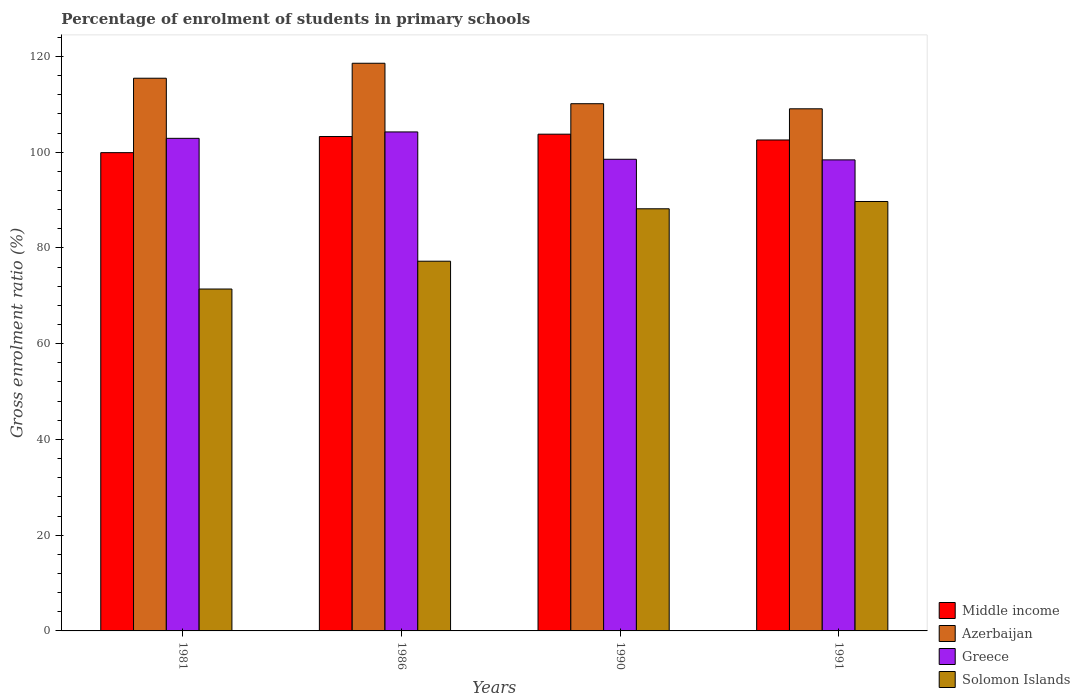How many groups of bars are there?
Keep it short and to the point. 4. Are the number of bars per tick equal to the number of legend labels?
Offer a very short reply. Yes. Are the number of bars on each tick of the X-axis equal?
Offer a terse response. Yes. How many bars are there on the 2nd tick from the left?
Provide a succinct answer. 4. What is the label of the 3rd group of bars from the left?
Give a very brief answer. 1990. In how many cases, is the number of bars for a given year not equal to the number of legend labels?
Provide a short and direct response. 0. What is the percentage of students enrolled in primary schools in Middle income in 1990?
Keep it short and to the point. 103.76. Across all years, what is the maximum percentage of students enrolled in primary schools in Azerbaijan?
Give a very brief answer. 118.57. Across all years, what is the minimum percentage of students enrolled in primary schools in Greece?
Your answer should be compact. 98.39. In which year was the percentage of students enrolled in primary schools in Solomon Islands minimum?
Provide a succinct answer. 1981. What is the total percentage of students enrolled in primary schools in Middle income in the graph?
Ensure brevity in your answer.  409.47. What is the difference between the percentage of students enrolled in primary schools in Azerbaijan in 1990 and that in 1991?
Give a very brief answer. 1.06. What is the difference between the percentage of students enrolled in primary schools in Middle income in 1986 and the percentage of students enrolled in primary schools in Azerbaijan in 1990?
Keep it short and to the point. -6.86. What is the average percentage of students enrolled in primary schools in Middle income per year?
Your answer should be very brief. 102.37. In the year 1981, what is the difference between the percentage of students enrolled in primary schools in Solomon Islands and percentage of students enrolled in primary schools in Azerbaijan?
Make the answer very short. -44.03. What is the ratio of the percentage of students enrolled in primary schools in Azerbaijan in 1990 to that in 1991?
Make the answer very short. 1.01. Is the difference between the percentage of students enrolled in primary schools in Solomon Islands in 1990 and 1991 greater than the difference between the percentage of students enrolled in primary schools in Azerbaijan in 1990 and 1991?
Make the answer very short. No. What is the difference between the highest and the second highest percentage of students enrolled in primary schools in Solomon Islands?
Offer a terse response. 1.52. What is the difference between the highest and the lowest percentage of students enrolled in primary schools in Azerbaijan?
Your answer should be very brief. 9.51. In how many years, is the percentage of students enrolled in primary schools in Middle income greater than the average percentage of students enrolled in primary schools in Middle income taken over all years?
Your answer should be very brief. 3. Is the sum of the percentage of students enrolled in primary schools in Solomon Islands in 1986 and 1990 greater than the maximum percentage of students enrolled in primary schools in Middle income across all years?
Provide a short and direct response. Yes. What does the 2nd bar from the left in 1981 represents?
Provide a succinct answer. Azerbaijan. Is it the case that in every year, the sum of the percentage of students enrolled in primary schools in Greece and percentage of students enrolled in primary schools in Solomon Islands is greater than the percentage of students enrolled in primary schools in Middle income?
Keep it short and to the point. Yes. How many bars are there?
Ensure brevity in your answer.  16. Are all the bars in the graph horizontal?
Keep it short and to the point. No. Where does the legend appear in the graph?
Keep it short and to the point. Bottom right. How many legend labels are there?
Provide a succinct answer. 4. What is the title of the graph?
Ensure brevity in your answer.  Percentage of enrolment of students in primary schools. Does "Lithuania" appear as one of the legend labels in the graph?
Offer a very short reply. No. What is the Gross enrolment ratio (%) in Middle income in 1981?
Make the answer very short. 99.9. What is the Gross enrolment ratio (%) in Azerbaijan in 1981?
Provide a succinct answer. 115.44. What is the Gross enrolment ratio (%) in Greece in 1981?
Provide a short and direct response. 102.89. What is the Gross enrolment ratio (%) in Solomon Islands in 1981?
Keep it short and to the point. 71.41. What is the Gross enrolment ratio (%) in Middle income in 1986?
Make the answer very short. 103.27. What is the Gross enrolment ratio (%) of Azerbaijan in 1986?
Offer a terse response. 118.57. What is the Gross enrolment ratio (%) of Greece in 1986?
Offer a terse response. 104.22. What is the Gross enrolment ratio (%) of Solomon Islands in 1986?
Your answer should be very brief. 77.22. What is the Gross enrolment ratio (%) in Middle income in 1990?
Your response must be concise. 103.76. What is the Gross enrolment ratio (%) of Azerbaijan in 1990?
Make the answer very short. 110.12. What is the Gross enrolment ratio (%) in Greece in 1990?
Offer a terse response. 98.51. What is the Gross enrolment ratio (%) of Solomon Islands in 1990?
Your answer should be compact. 88.17. What is the Gross enrolment ratio (%) in Middle income in 1991?
Make the answer very short. 102.55. What is the Gross enrolment ratio (%) of Azerbaijan in 1991?
Make the answer very short. 109.06. What is the Gross enrolment ratio (%) in Greece in 1991?
Ensure brevity in your answer.  98.39. What is the Gross enrolment ratio (%) of Solomon Islands in 1991?
Provide a short and direct response. 89.7. Across all years, what is the maximum Gross enrolment ratio (%) of Middle income?
Offer a terse response. 103.76. Across all years, what is the maximum Gross enrolment ratio (%) in Azerbaijan?
Your answer should be compact. 118.57. Across all years, what is the maximum Gross enrolment ratio (%) in Greece?
Give a very brief answer. 104.22. Across all years, what is the maximum Gross enrolment ratio (%) of Solomon Islands?
Your response must be concise. 89.7. Across all years, what is the minimum Gross enrolment ratio (%) of Middle income?
Your response must be concise. 99.9. Across all years, what is the minimum Gross enrolment ratio (%) of Azerbaijan?
Your answer should be very brief. 109.06. Across all years, what is the minimum Gross enrolment ratio (%) of Greece?
Make the answer very short. 98.39. Across all years, what is the minimum Gross enrolment ratio (%) of Solomon Islands?
Give a very brief answer. 71.41. What is the total Gross enrolment ratio (%) in Middle income in the graph?
Your answer should be very brief. 409.47. What is the total Gross enrolment ratio (%) of Azerbaijan in the graph?
Offer a very short reply. 453.19. What is the total Gross enrolment ratio (%) in Greece in the graph?
Your answer should be very brief. 404.01. What is the total Gross enrolment ratio (%) in Solomon Islands in the graph?
Provide a succinct answer. 326.51. What is the difference between the Gross enrolment ratio (%) of Middle income in 1981 and that in 1986?
Provide a succinct answer. -3.37. What is the difference between the Gross enrolment ratio (%) of Azerbaijan in 1981 and that in 1986?
Provide a succinct answer. -3.13. What is the difference between the Gross enrolment ratio (%) of Greece in 1981 and that in 1986?
Give a very brief answer. -1.34. What is the difference between the Gross enrolment ratio (%) of Solomon Islands in 1981 and that in 1986?
Make the answer very short. -5.81. What is the difference between the Gross enrolment ratio (%) in Middle income in 1981 and that in 1990?
Provide a succinct answer. -3.86. What is the difference between the Gross enrolment ratio (%) in Azerbaijan in 1981 and that in 1990?
Provide a short and direct response. 5.32. What is the difference between the Gross enrolment ratio (%) of Greece in 1981 and that in 1990?
Offer a terse response. 4.38. What is the difference between the Gross enrolment ratio (%) of Solomon Islands in 1981 and that in 1990?
Provide a succinct answer. -16.76. What is the difference between the Gross enrolment ratio (%) of Middle income in 1981 and that in 1991?
Offer a very short reply. -2.65. What is the difference between the Gross enrolment ratio (%) in Azerbaijan in 1981 and that in 1991?
Your answer should be very brief. 6.39. What is the difference between the Gross enrolment ratio (%) of Greece in 1981 and that in 1991?
Your answer should be compact. 4.5. What is the difference between the Gross enrolment ratio (%) of Solomon Islands in 1981 and that in 1991?
Your answer should be compact. -18.28. What is the difference between the Gross enrolment ratio (%) of Middle income in 1986 and that in 1990?
Your response must be concise. -0.49. What is the difference between the Gross enrolment ratio (%) of Azerbaijan in 1986 and that in 1990?
Offer a very short reply. 8.45. What is the difference between the Gross enrolment ratio (%) of Greece in 1986 and that in 1990?
Offer a very short reply. 5.71. What is the difference between the Gross enrolment ratio (%) in Solomon Islands in 1986 and that in 1990?
Your answer should be very brief. -10.95. What is the difference between the Gross enrolment ratio (%) of Middle income in 1986 and that in 1991?
Ensure brevity in your answer.  0.72. What is the difference between the Gross enrolment ratio (%) in Azerbaijan in 1986 and that in 1991?
Provide a succinct answer. 9.51. What is the difference between the Gross enrolment ratio (%) in Greece in 1986 and that in 1991?
Keep it short and to the point. 5.84. What is the difference between the Gross enrolment ratio (%) in Solomon Islands in 1986 and that in 1991?
Give a very brief answer. -12.47. What is the difference between the Gross enrolment ratio (%) of Middle income in 1990 and that in 1991?
Your answer should be very brief. 1.21. What is the difference between the Gross enrolment ratio (%) of Azerbaijan in 1990 and that in 1991?
Your answer should be very brief. 1.06. What is the difference between the Gross enrolment ratio (%) in Greece in 1990 and that in 1991?
Your answer should be compact. 0.13. What is the difference between the Gross enrolment ratio (%) of Solomon Islands in 1990 and that in 1991?
Provide a short and direct response. -1.52. What is the difference between the Gross enrolment ratio (%) of Middle income in 1981 and the Gross enrolment ratio (%) of Azerbaijan in 1986?
Give a very brief answer. -18.67. What is the difference between the Gross enrolment ratio (%) of Middle income in 1981 and the Gross enrolment ratio (%) of Greece in 1986?
Offer a very short reply. -4.32. What is the difference between the Gross enrolment ratio (%) in Middle income in 1981 and the Gross enrolment ratio (%) in Solomon Islands in 1986?
Keep it short and to the point. 22.68. What is the difference between the Gross enrolment ratio (%) of Azerbaijan in 1981 and the Gross enrolment ratio (%) of Greece in 1986?
Give a very brief answer. 11.22. What is the difference between the Gross enrolment ratio (%) of Azerbaijan in 1981 and the Gross enrolment ratio (%) of Solomon Islands in 1986?
Your response must be concise. 38.22. What is the difference between the Gross enrolment ratio (%) of Greece in 1981 and the Gross enrolment ratio (%) of Solomon Islands in 1986?
Your answer should be very brief. 25.67. What is the difference between the Gross enrolment ratio (%) of Middle income in 1981 and the Gross enrolment ratio (%) of Azerbaijan in 1990?
Your response must be concise. -10.22. What is the difference between the Gross enrolment ratio (%) of Middle income in 1981 and the Gross enrolment ratio (%) of Greece in 1990?
Your response must be concise. 1.39. What is the difference between the Gross enrolment ratio (%) of Middle income in 1981 and the Gross enrolment ratio (%) of Solomon Islands in 1990?
Offer a very short reply. 11.73. What is the difference between the Gross enrolment ratio (%) in Azerbaijan in 1981 and the Gross enrolment ratio (%) in Greece in 1990?
Offer a very short reply. 16.93. What is the difference between the Gross enrolment ratio (%) of Azerbaijan in 1981 and the Gross enrolment ratio (%) of Solomon Islands in 1990?
Your answer should be compact. 27.27. What is the difference between the Gross enrolment ratio (%) of Greece in 1981 and the Gross enrolment ratio (%) of Solomon Islands in 1990?
Provide a short and direct response. 14.72. What is the difference between the Gross enrolment ratio (%) in Middle income in 1981 and the Gross enrolment ratio (%) in Azerbaijan in 1991?
Provide a short and direct response. -9.16. What is the difference between the Gross enrolment ratio (%) in Middle income in 1981 and the Gross enrolment ratio (%) in Greece in 1991?
Offer a very short reply. 1.51. What is the difference between the Gross enrolment ratio (%) in Middle income in 1981 and the Gross enrolment ratio (%) in Solomon Islands in 1991?
Provide a short and direct response. 10.2. What is the difference between the Gross enrolment ratio (%) of Azerbaijan in 1981 and the Gross enrolment ratio (%) of Greece in 1991?
Provide a short and direct response. 17.06. What is the difference between the Gross enrolment ratio (%) of Azerbaijan in 1981 and the Gross enrolment ratio (%) of Solomon Islands in 1991?
Provide a short and direct response. 25.75. What is the difference between the Gross enrolment ratio (%) in Greece in 1981 and the Gross enrolment ratio (%) in Solomon Islands in 1991?
Provide a succinct answer. 13.19. What is the difference between the Gross enrolment ratio (%) of Middle income in 1986 and the Gross enrolment ratio (%) of Azerbaijan in 1990?
Give a very brief answer. -6.86. What is the difference between the Gross enrolment ratio (%) of Middle income in 1986 and the Gross enrolment ratio (%) of Greece in 1990?
Your answer should be compact. 4.75. What is the difference between the Gross enrolment ratio (%) in Middle income in 1986 and the Gross enrolment ratio (%) in Solomon Islands in 1990?
Your answer should be very brief. 15.09. What is the difference between the Gross enrolment ratio (%) in Azerbaijan in 1986 and the Gross enrolment ratio (%) in Greece in 1990?
Give a very brief answer. 20.06. What is the difference between the Gross enrolment ratio (%) of Azerbaijan in 1986 and the Gross enrolment ratio (%) of Solomon Islands in 1990?
Provide a short and direct response. 30.4. What is the difference between the Gross enrolment ratio (%) of Greece in 1986 and the Gross enrolment ratio (%) of Solomon Islands in 1990?
Give a very brief answer. 16.05. What is the difference between the Gross enrolment ratio (%) of Middle income in 1986 and the Gross enrolment ratio (%) of Azerbaijan in 1991?
Offer a terse response. -5.79. What is the difference between the Gross enrolment ratio (%) of Middle income in 1986 and the Gross enrolment ratio (%) of Greece in 1991?
Keep it short and to the point. 4.88. What is the difference between the Gross enrolment ratio (%) of Middle income in 1986 and the Gross enrolment ratio (%) of Solomon Islands in 1991?
Your answer should be very brief. 13.57. What is the difference between the Gross enrolment ratio (%) of Azerbaijan in 1986 and the Gross enrolment ratio (%) of Greece in 1991?
Offer a terse response. 20.18. What is the difference between the Gross enrolment ratio (%) in Azerbaijan in 1986 and the Gross enrolment ratio (%) in Solomon Islands in 1991?
Your answer should be compact. 28.87. What is the difference between the Gross enrolment ratio (%) of Greece in 1986 and the Gross enrolment ratio (%) of Solomon Islands in 1991?
Offer a terse response. 14.53. What is the difference between the Gross enrolment ratio (%) in Middle income in 1990 and the Gross enrolment ratio (%) in Azerbaijan in 1991?
Make the answer very short. -5.3. What is the difference between the Gross enrolment ratio (%) in Middle income in 1990 and the Gross enrolment ratio (%) in Greece in 1991?
Provide a succinct answer. 5.37. What is the difference between the Gross enrolment ratio (%) in Middle income in 1990 and the Gross enrolment ratio (%) in Solomon Islands in 1991?
Provide a succinct answer. 14.06. What is the difference between the Gross enrolment ratio (%) in Azerbaijan in 1990 and the Gross enrolment ratio (%) in Greece in 1991?
Give a very brief answer. 11.73. What is the difference between the Gross enrolment ratio (%) of Azerbaijan in 1990 and the Gross enrolment ratio (%) of Solomon Islands in 1991?
Make the answer very short. 20.43. What is the difference between the Gross enrolment ratio (%) in Greece in 1990 and the Gross enrolment ratio (%) in Solomon Islands in 1991?
Provide a short and direct response. 8.82. What is the average Gross enrolment ratio (%) in Middle income per year?
Provide a short and direct response. 102.37. What is the average Gross enrolment ratio (%) of Azerbaijan per year?
Your answer should be compact. 113.3. What is the average Gross enrolment ratio (%) in Greece per year?
Your answer should be very brief. 101. What is the average Gross enrolment ratio (%) of Solomon Islands per year?
Your answer should be very brief. 81.63. In the year 1981, what is the difference between the Gross enrolment ratio (%) of Middle income and Gross enrolment ratio (%) of Azerbaijan?
Your response must be concise. -15.54. In the year 1981, what is the difference between the Gross enrolment ratio (%) in Middle income and Gross enrolment ratio (%) in Greece?
Provide a succinct answer. -2.99. In the year 1981, what is the difference between the Gross enrolment ratio (%) of Middle income and Gross enrolment ratio (%) of Solomon Islands?
Your answer should be very brief. 28.49. In the year 1981, what is the difference between the Gross enrolment ratio (%) of Azerbaijan and Gross enrolment ratio (%) of Greece?
Make the answer very short. 12.56. In the year 1981, what is the difference between the Gross enrolment ratio (%) in Azerbaijan and Gross enrolment ratio (%) in Solomon Islands?
Provide a succinct answer. 44.03. In the year 1981, what is the difference between the Gross enrolment ratio (%) in Greece and Gross enrolment ratio (%) in Solomon Islands?
Your answer should be very brief. 31.47. In the year 1986, what is the difference between the Gross enrolment ratio (%) of Middle income and Gross enrolment ratio (%) of Azerbaijan?
Offer a terse response. -15.3. In the year 1986, what is the difference between the Gross enrolment ratio (%) in Middle income and Gross enrolment ratio (%) in Greece?
Provide a short and direct response. -0.96. In the year 1986, what is the difference between the Gross enrolment ratio (%) of Middle income and Gross enrolment ratio (%) of Solomon Islands?
Offer a terse response. 26.04. In the year 1986, what is the difference between the Gross enrolment ratio (%) of Azerbaijan and Gross enrolment ratio (%) of Greece?
Offer a very short reply. 14.35. In the year 1986, what is the difference between the Gross enrolment ratio (%) of Azerbaijan and Gross enrolment ratio (%) of Solomon Islands?
Offer a very short reply. 41.35. In the year 1986, what is the difference between the Gross enrolment ratio (%) in Greece and Gross enrolment ratio (%) in Solomon Islands?
Provide a succinct answer. 27. In the year 1990, what is the difference between the Gross enrolment ratio (%) in Middle income and Gross enrolment ratio (%) in Azerbaijan?
Offer a very short reply. -6.37. In the year 1990, what is the difference between the Gross enrolment ratio (%) of Middle income and Gross enrolment ratio (%) of Greece?
Your response must be concise. 5.24. In the year 1990, what is the difference between the Gross enrolment ratio (%) in Middle income and Gross enrolment ratio (%) in Solomon Islands?
Your answer should be compact. 15.58. In the year 1990, what is the difference between the Gross enrolment ratio (%) of Azerbaijan and Gross enrolment ratio (%) of Greece?
Your answer should be very brief. 11.61. In the year 1990, what is the difference between the Gross enrolment ratio (%) of Azerbaijan and Gross enrolment ratio (%) of Solomon Islands?
Your answer should be compact. 21.95. In the year 1990, what is the difference between the Gross enrolment ratio (%) of Greece and Gross enrolment ratio (%) of Solomon Islands?
Provide a succinct answer. 10.34. In the year 1991, what is the difference between the Gross enrolment ratio (%) of Middle income and Gross enrolment ratio (%) of Azerbaijan?
Your response must be concise. -6.51. In the year 1991, what is the difference between the Gross enrolment ratio (%) in Middle income and Gross enrolment ratio (%) in Greece?
Offer a terse response. 4.16. In the year 1991, what is the difference between the Gross enrolment ratio (%) of Middle income and Gross enrolment ratio (%) of Solomon Islands?
Your answer should be very brief. 12.85. In the year 1991, what is the difference between the Gross enrolment ratio (%) of Azerbaijan and Gross enrolment ratio (%) of Greece?
Provide a succinct answer. 10.67. In the year 1991, what is the difference between the Gross enrolment ratio (%) of Azerbaijan and Gross enrolment ratio (%) of Solomon Islands?
Your answer should be very brief. 19.36. In the year 1991, what is the difference between the Gross enrolment ratio (%) in Greece and Gross enrolment ratio (%) in Solomon Islands?
Provide a succinct answer. 8.69. What is the ratio of the Gross enrolment ratio (%) in Middle income in 1981 to that in 1986?
Make the answer very short. 0.97. What is the ratio of the Gross enrolment ratio (%) in Azerbaijan in 1981 to that in 1986?
Give a very brief answer. 0.97. What is the ratio of the Gross enrolment ratio (%) of Greece in 1981 to that in 1986?
Offer a very short reply. 0.99. What is the ratio of the Gross enrolment ratio (%) in Solomon Islands in 1981 to that in 1986?
Keep it short and to the point. 0.92. What is the ratio of the Gross enrolment ratio (%) in Middle income in 1981 to that in 1990?
Ensure brevity in your answer.  0.96. What is the ratio of the Gross enrolment ratio (%) in Azerbaijan in 1981 to that in 1990?
Your answer should be compact. 1.05. What is the ratio of the Gross enrolment ratio (%) of Greece in 1981 to that in 1990?
Your answer should be very brief. 1.04. What is the ratio of the Gross enrolment ratio (%) in Solomon Islands in 1981 to that in 1990?
Make the answer very short. 0.81. What is the ratio of the Gross enrolment ratio (%) in Middle income in 1981 to that in 1991?
Offer a very short reply. 0.97. What is the ratio of the Gross enrolment ratio (%) of Azerbaijan in 1981 to that in 1991?
Give a very brief answer. 1.06. What is the ratio of the Gross enrolment ratio (%) of Greece in 1981 to that in 1991?
Keep it short and to the point. 1.05. What is the ratio of the Gross enrolment ratio (%) of Solomon Islands in 1981 to that in 1991?
Offer a terse response. 0.8. What is the ratio of the Gross enrolment ratio (%) in Middle income in 1986 to that in 1990?
Offer a very short reply. 1. What is the ratio of the Gross enrolment ratio (%) of Azerbaijan in 1986 to that in 1990?
Your answer should be very brief. 1.08. What is the ratio of the Gross enrolment ratio (%) in Greece in 1986 to that in 1990?
Keep it short and to the point. 1.06. What is the ratio of the Gross enrolment ratio (%) of Solomon Islands in 1986 to that in 1990?
Make the answer very short. 0.88. What is the ratio of the Gross enrolment ratio (%) in Middle income in 1986 to that in 1991?
Provide a short and direct response. 1.01. What is the ratio of the Gross enrolment ratio (%) of Azerbaijan in 1986 to that in 1991?
Keep it short and to the point. 1.09. What is the ratio of the Gross enrolment ratio (%) of Greece in 1986 to that in 1991?
Keep it short and to the point. 1.06. What is the ratio of the Gross enrolment ratio (%) of Solomon Islands in 1986 to that in 1991?
Your answer should be very brief. 0.86. What is the ratio of the Gross enrolment ratio (%) in Middle income in 1990 to that in 1991?
Your answer should be very brief. 1.01. What is the ratio of the Gross enrolment ratio (%) of Azerbaijan in 1990 to that in 1991?
Your answer should be compact. 1.01. What is the ratio of the Gross enrolment ratio (%) of Solomon Islands in 1990 to that in 1991?
Make the answer very short. 0.98. What is the difference between the highest and the second highest Gross enrolment ratio (%) of Middle income?
Make the answer very short. 0.49. What is the difference between the highest and the second highest Gross enrolment ratio (%) of Azerbaijan?
Ensure brevity in your answer.  3.13. What is the difference between the highest and the second highest Gross enrolment ratio (%) of Greece?
Provide a succinct answer. 1.34. What is the difference between the highest and the second highest Gross enrolment ratio (%) of Solomon Islands?
Provide a succinct answer. 1.52. What is the difference between the highest and the lowest Gross enrolment ratio (%) in Middle income?
Offer a very short reply. 3.86. What is the difference between the highest and the lowest Gross enrolment ratio (%) in Azerbaijan?
Provide a succinct answer. 9.51. What is the difference between the highest and the lowest Gross enrolment ratio (%) of Greece?
Offer a terse response. 5.84. What is the difference between the highest and the lowest Gross enrolment ratio (%) in Solomon Islands?
Make the answer very short. 18.28. 